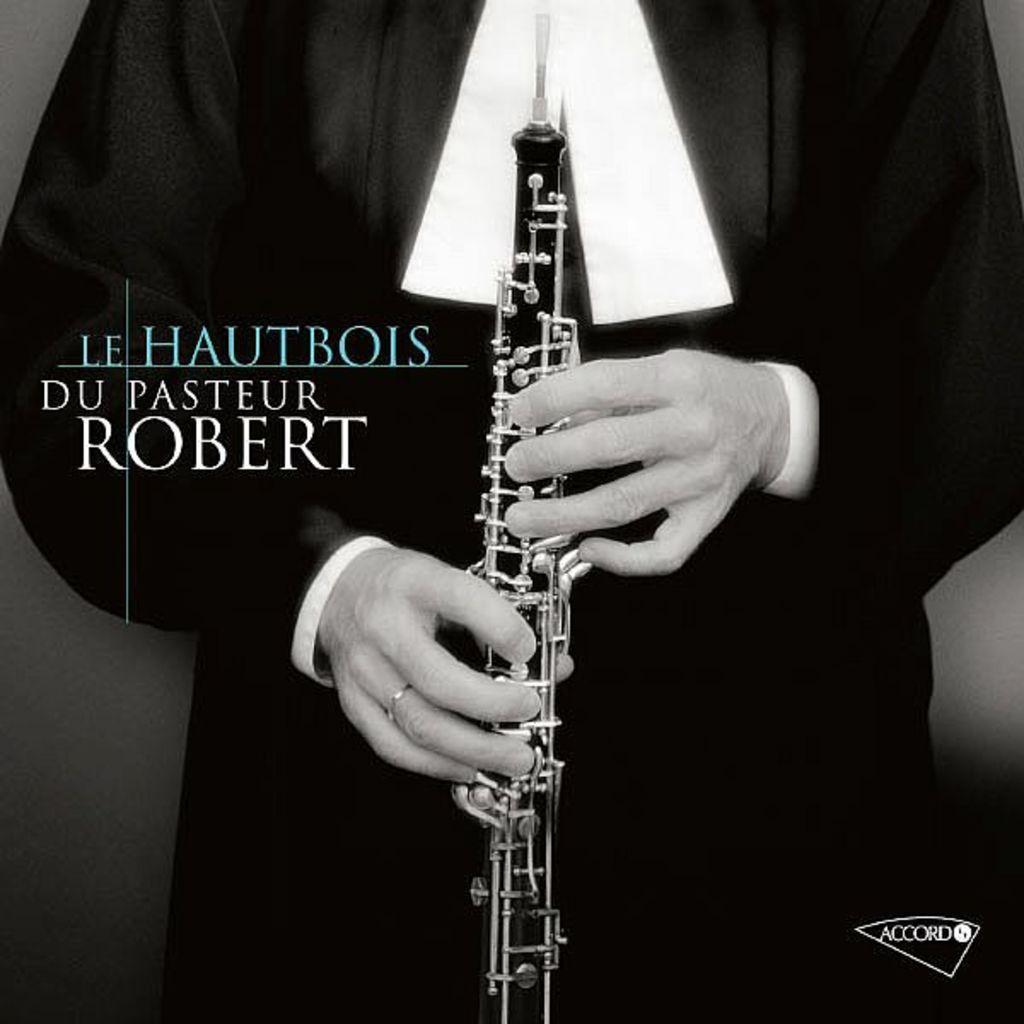How would you summarize this image in a sentence or two? In this image I can see a person holding musical instrument. He is wearing black and white dress and background is black in color. 